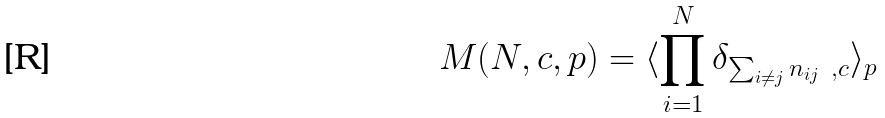Convert formula to latex. <formula><loc_0><loc_0><loc_500><loc_500>M ( N , c , p ) = \langle \prod _ { i = 1 } ^ { N } \delta _ { \sum _ { i \neq j } n _ { i j } \ , c } \rangle _ { p }</formula> 